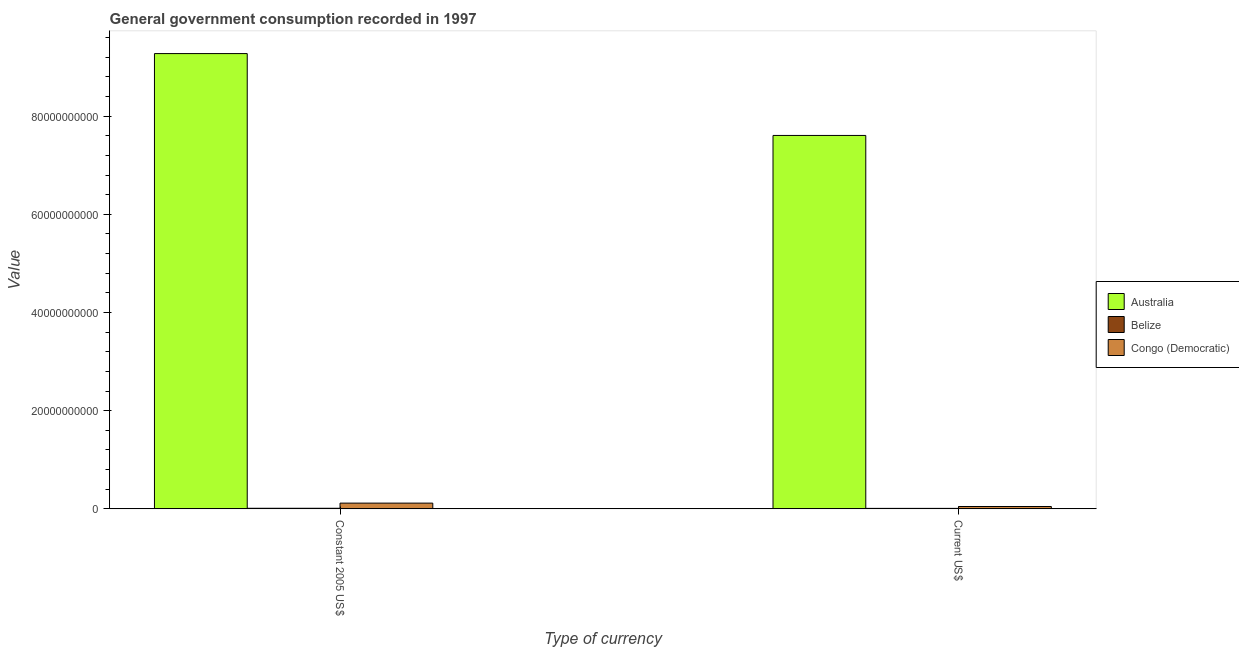Are the number of bars per tick equal to the number of legend labels?
Provide a short and direct response. Yes. How many bars are there on the 2nd tick from the left?
Provide a short and direct response. 3. How many bars are there on the 1st tick from the right?
Provide a succinct answer. 3. What is the label of the 1st group of bars from the left?
Make the answer very short. Constant 2005 US$. What is the value consumed in constant 2005 us$ in Congo (Democratic)?
Give a very brief answer. 1.17e+09. Across all countries, what is the maximum value consumed in constant 2005 us$?
Give a very brief answer. 9.27e+1. Across all countries, what is the minimum value consumed in constant 2005 us$?
Ensure brevity in your answer.  1.16e+08. In which country was the value consumed in current us$ minimum?
Keep it short and to the point. Belize. What is the total value consumed in constant 2005 us$ in the graph?
Your answer should be very brief. 9.40e+1. What is the difference between the value consumed in constant 2005 us$ in Belize and that in Congo (Democratic)?
Offer a terse response. -1.05e+09. What is the difference between the value consumed in current us$ in Belize and the value consumed in constant 2005 us$ in Australia?
Offer a terse response. -9.26e+1. What is the average value consumed in constant 2005 us$ per country?
Provide a short and direct response. 3.13e+1. What is the difference between the value consumed in constant 2005 us$ and value consumed in current us$ in Belize?
Your answer should be compact. 2.09e+07. In how many countries, is the value consumed in constant 2005 us$ greater than 52000000000 ?
Your response must be concise. 1. What is the ratio of the value consumed in current us$ in Congo (Democratic) to that in Australia?
Ensure brevity in your answer.  0.01. In how many countries, is the value consumed in current us$ greater than the average value consumed in current us$ taken over all countries?
Your answer should be compact. 1. How many bars are there?
Make the answer very short. 6. Does the graph contain grids?
Ensure brevity in your answer.  No. Where does the legend appear in the graph?
Provide a succinct answer. Center right. What is the title of the graph?
Keep it short and to the point. General government consumption recorded in 1997. What is the label or title of the X-axis?
Provide a short and direct response. Type of currency. What is the label or title of the Y-axis?
Keep it short and to the point. Value. What is the Value of Australia in Constant 2005 US$?
Keep it short and to the point. 9.27e+1. What is the Value in Belize in Constant 2005 US$?
Ensure brevity in your answer.  1.16e+08. What is the Value in Congo (Democratic) in Constant 2005 US$?
Provide a succinct answer. 1.17e+09. What is the Value of Australia in Current US$?
Offer a terse response. 7.61e+1. What is the Value in Belize in Current US$?
Ensure brevity in your answer.  9.51e+07. What is the Value in Congo (Democratic) in Current US$?
Your answer should be compact. 4.75e+08. Across all Type of currency, what is the maximum Value in Australia?
Your response must be concise. 9.27e+1. Across all Type of currency, what is the maximum Value of Belize?
Offer a very short reply. 1.16e+08. Across all Type of currency, what is the maximum Value of Congo (Democratic)?
Make the answer very short. 1.17e+09. Across all Type of currency, what is the minimum Value in Australia?
Offer a terse response. 7.61e+1. Across all Type of currency, what is the minimum Value of Belize?
Your answer should be compact. 9.51e+07. Across all Type of currency, what is the minimum Value in Congo (Democratic)?
Offer a terse response. 4.75e+08. What is the total Value of Australia in the graph?
Keep it short and to the point. 1.69e+11. What is the total Value in Belize in the graph?
Give a very brief answer. 2.11e+08. What is the total Value in Congo (Democratic) in the graph?
Offer a very short reply. 1.64e+09. What is the difference between the Value of Australia in Constant 2005 US$ and that in Current US$?
Offer a very short reply. 1.67e+1. What is the difference between the Value in Belize in Constant 2005 US$ and that in Current US$?
Provide a succinct answer. 2.09e+07. What is the difference between the Value in Congo (Democratic) in Constant 2005 US$ and that in Current US$?
Keep it short and to the point. 6.92e+08. What is the difference between the Value in Australia in Constant 2005 US$ and the Value in Belize in Current US$?
Offer a very short reply. 9.26e+1. What is the difference between the Value of Australia in Constant 2005 US$ and the Value of Congo (Democratic) in Current US$?
Your response must be concise. 9.23e+1. What is the difference between the Value in Belize in Constant 2005 US$ and the Value in Congo (Democratic) in Current US$?
Keep it short and to the point. -3.59e+08. What is the average Value in Australia per Type of currency?
Give a very brief answer. 8.44e+1. What is the average Value of Belize per Type of currency?
Make the answer very short. 1.06e+08. What is the average Value of Congo (Democratic) per Type of currency?
Your answer should be compact. 8.21e+08. What is the difference between the Value of Australia and Value of Belize in Constant 2005 US$?
Your response must be concise. 9.26e+1. What is the difference between the Value in Australia and Value in Congo (Democratic) in Constant 2005 US$?
Your answer should be compact. 9.16e+1. What is the difference between the Value of Belize and Value of Congo (Democratic) in Constant 2005 US$?
Keep it short and to the point. -1.05e+09. What is the difference between the Value in Australia and Value in Belize in Current US$?
Your answer should be compact. 7.60e+1. What is the difference between the Value of Australia and Value of Congo (Democratic) in Current US$?
Offer a terse response. 7.56e+1. What is the difference between the Value of Belize and Value of Congo (Democratic) in Current US$?
Provide a short and direct response. -3.80e+08. What is the ratio of the Value in Australia in Constant 2005 US$ to that in Current US$?
Your answer should be compact. 1.22. What is the ratio of the Value in Belize in Constant 2005 US$ to that in Current US$?
Provide a short and direct response. 1.22. What is the ratio of the Value in Congo (Democratic) in Constant 2005 US$ to that in Current US$?
Provide a short and direct response. 2.46. What is the difference between the highest and the second highest Value of Australia?
Offer a terse response. 1.67e+1. What is the difference between the highest and the second highest Value of Belize?
Offer a terse response. 2.09e+07. What is the difference between the highest and the second highest Value of Congo (Democratic)?
Your response must be concise. 6.92e+08. What is the difference between the highest and the lowest Value in Australia?
Give a very brief answer. 1.67e+1. What is the difference between the highest and the lowest Value of Belize?
Keep it short and to the point. 2.09e+07. What is the difference between the highest and the lowest Value in Congo (Democratic)?
Provide a succinct answer. 6.92e+08. 